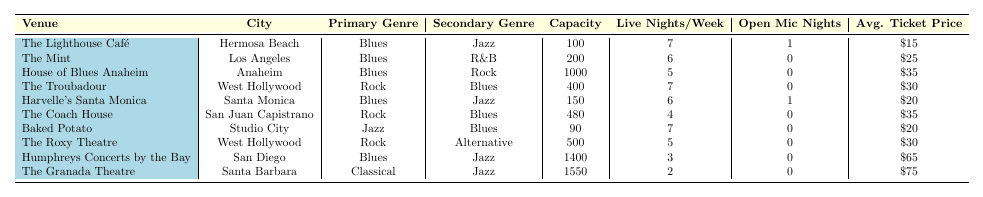What is the capacity of The Lighthouse Café? The table lists the details for each venue, and under The Lighthouse Café, the capacity is noted as 100.
Answer: 100 How many live nights per week does the House of Blues Anaheim have? The table shows that House of Blues Anaheim has 5 live nights per week listed next to it.
Answer: 5 Which venue in Santa Monica has Blues as the primary genre? Looking at the venue names and their respective cities, Harvelle's Santa Monica is the venue listed under Santa Monica with Blues as the primary genre.
Answer: Harvelle's Santa Monica What is the average ticket price for venues with a capacity over 500? Only Humphreys Concerts by the Bay (capacity 1400) and The Granada Theatre (capacity 1550) have a capacity over 500. The ticket prices are $65 and $75 respectively. The average is calculated as (65 + 75) / 2 = 70.
Answer: 70 Which venue has the highest capacity and what genre do they primarily feature? The table indicates that Humphreys Concerts by the Bay has the highest capacity at 1400 and features Blues as the primary genre.
Answer: Humphreys Concerts by the Bay, Blues How many venues feature Blues as either their primary or secondary genre? The venues that feature Blues are The Lighthouse Café, The Mint, House of Blues Anaheim, Harvelle's Santa Monica, The Coach House, Baked Potato, and Humphreys Concerts by the Bay. That totals 7 venues.
Answer: 7 Is there a venue that offers open mic nights and also has Blues as the primary genre? The Lighthouse Café and Harvelle's Santa Monica both have open mic nights (1 each) and feature Blues as their primary genre as indicated in the table.
Answer: Yes What is the difference in average ticket prices between venues featuring Blues and those featuring Rock as the primary genre? The average ticket price for Blues venues (calculated as ($15 + $25 + $35 + $20 + $65) / 5 = 24) and for Rock venues ($30 + $35 = $32.5) gives a difference of $24 - $32.5 = -8.5, meaning Rock venues have a higher average ticket price.
Answer: -8.5 Which city hosts the venue with the most live nights per week and what is its primary genre? West Hollywood has The Troubadour, which features Rock with 7 live nights per week. Comparing with other cities, none show more than 7 live nights.
Answer: West Hollywood, Rock Are there any venues that feature Jazz as their primary genre? Yes, Baked Potato is the only venue listed with Jazz as the primary genre in the table.
Answer: Yes 